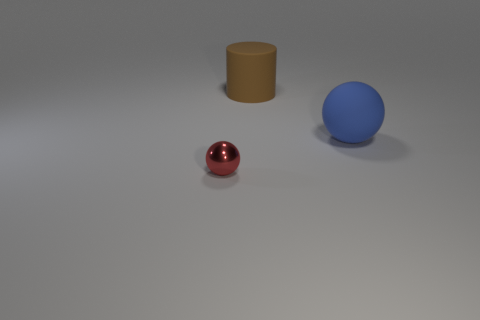Are the red thing and the large cylinder made of the same material?
Ensure brevity in your answer.  No. How many tiny yellow blocks are there?
Your answer should be compact. 0. There is a ball that is to the left of the large thing that is right of the matte thing that is on the left side of the large blue matte ball; what color is it?
Ensure brevity in your answer.  Red. What number of objects are behind the tiny red metallic ball and left of the large blue ball?
Provide a short and direct response. 1. How many rubber objects are small cyan blocks or large cylinders?
Give a very brief answer. 1. What is the material of the object that is in front of the big matte thing on the right side of the large cylinder?
Ensure brevity in your answer.  Metal. The other matte object that is the same size as the blue thing is what shape?
Your answer should be very brief. Cylinder. Are there fewer red matte cylinders than red shiny things?
Provide a short and direct response. Yes. There is a sphere on the right side of the small red metallic thing; are there any tiny red shiny spheres that are on the right side of it?
Offer a very short reply. No. The blue thing that is made of the same material as the brown thing is what shape?
Offer a terse response. Sphere. 